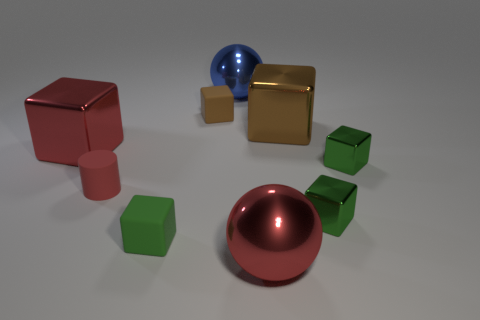Subtract all green cubes. How many were subtracted if there are1green cubes left? 2 Subtract all blue cylinders. How many green cubes are left? 3 Subtract all red cubes. How many cubes are left? 5 Subtract all red shiny cubes. How many cubes are left? 5 Subtract all yellow cubes. Subtract all green cylinders. How many cubes are left? 6 Subtract all balls. How many objects are left? 7 Subtract all red metallic things. Subtract all small brown cylinders. How many objects are left? 7 Add 6 large blue shiny things. How many large blue shiny things are left? 7 Add 6 tiny brown balls. How many tiny brown balls exist? 6 Subtract 0 cyan balls. How many objects are left? 9 